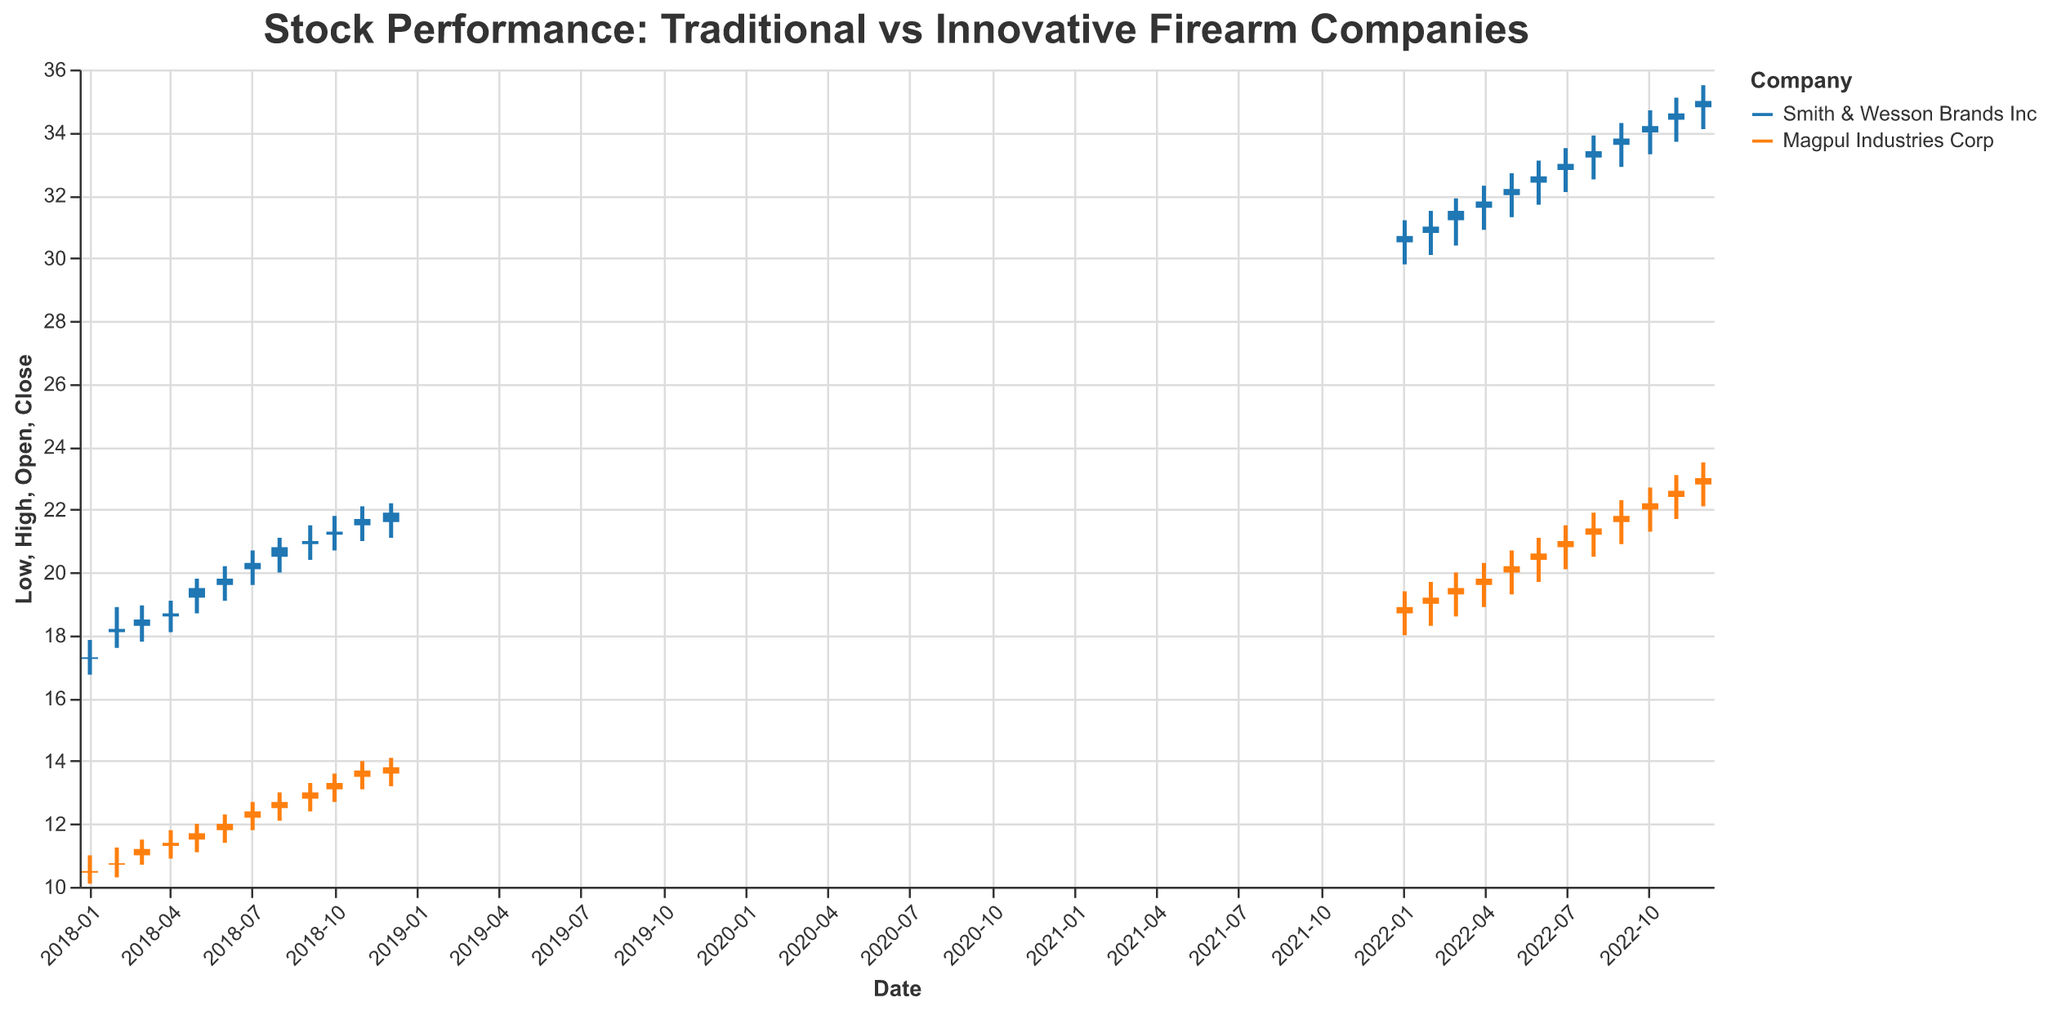**Basic Question Example 1**  
What are the two companies compared in the plot? The plot title and color legend indicate the two companies compared, which are Smith & Wesson Brands Inc and Magpul Industries Corp.
Answer: Smith & Wesson Brands Inc and Magpul Industries Corp **Compositional Question Example 1**  
What was the closing price of Smith & Wesson Brands Inc in January 2022 and how does it compare to its closing price in December 2022? To find these values, check the closing prices for January and December 2022 in the plot. Smith & Wesson Brands Inc had a closing price of 30.70 in January 2022 and 35.00 in December 2022. The difference is 35.00 - 30.70 = 4.30.
Answer: 4.30 difference **Comparison Question Example 1**  
Which company had a higher stock price in January 2022? To determine this, compare the closing prices of both companies in January 2022. Smith & Wesson Brands Inc closed at 30.70, whereas Magpul Industries Corp closed at 18.90. Smith & Wesson Brands Inc had a higher stock price.
Answer: Smith & Wesson Brands Inc **Chart-Type Specific Question Example 1**  
What does the thick vertical line in each candlestick represent in the plot? In a candlestick chart, the thick vertical line represents the range between the opening and closing prices for each period.
Answer: Opening and closing price range **Basic Question Example 2**  
How many years of data are presented in the plot? The x-axis ranges from January 2018 to December 2022, indicating data over five years.
Answer: Five years **Compositional Question Example 2**  
Calculate the average closing price for Magpul Industries Corp in 2018. Add up the closing prices for Magpul Industries Corp each month in 2018 and then divide by the number of months (12). Values are 10.50, 10.75, 11.20, 11.40, 11.70, 12.00, 12.40, 12.70, 13.00, 13.30, 13.70, 13.80. The sum is 146.45, thus the average is 146.45/12 = 12.20.
Answer: 12.20 **Comparison Question Example 2**  
Was the stock price change for Smith & Wesson Brands Inc more substantial than Magpul Industries Corp over the five-year period? To determine the overall change, compare the closing prices in January 2018 and December 2022 for both companies. Smith & Wesson Brands Inc: 17.30 (Jan 2018) to 35.00 (Dec 2022), change of 17.70. Magpul Industries Corp: 10.50 (Jan 2018) to 23.00 (Dec 2022), change of 12.50. Smith & Wesson Brands Inc had a larger change.
Answer: Yes, Smith & Wesson Brands Inc **Chart-Type Specific Question Example 2**  
What does the thin vertical line in each candlestick represent in the plot? In a candlestick chart, the wicks (thin vertical lines) represent the high and low prices for the period, showing the full extent of price movement.
Answer: High and low price range **Basic Question Example 3**  
What's the title of the plot? The title of the plot is "Stock Performance: Traditional vs Innovative Firearm Companies."
Answer: Stock Performance: Traditional vs Innovative Firearm Companies 